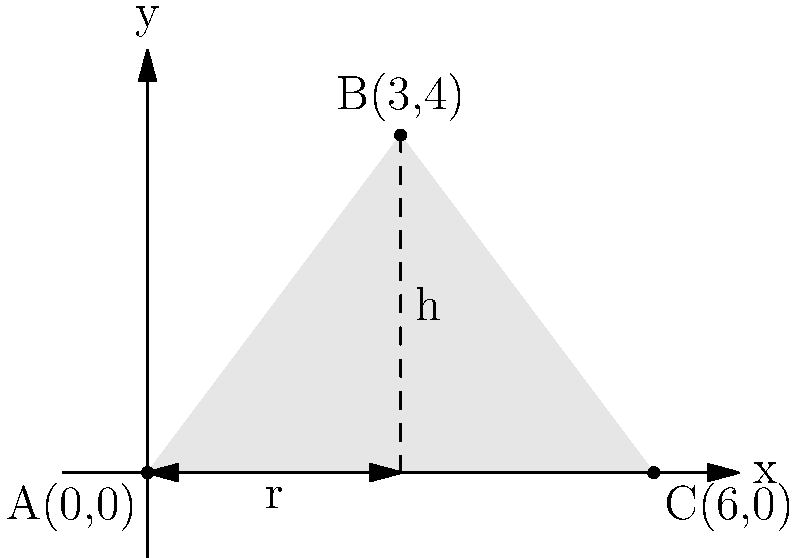As a traditional Egyptian farmer, you use a conical structure to store grains. The base of this structure is circular and rests on the ground. Given the coordinates of three points on the cone: A(0,0), B(3,4), and C(6,0), where the x and y axes are in meters, calculate the volume of the grain storage structure. Use $\pi \approx 3.14$ for your calculations. Let's approach this step-by-step:

1) First, we need to identify the radius and height of the cone:
   - The radius (r) is half the distance between A and C: $r = \frac{6}{2} = 3$ meters
   - The height (h) is the y-coordinate of point B: $h = 4$ meters

2) The volume of a cone is given by the formula: $V = \frac{1}{3}\pi r^2 h$

3) Substituting our values:
   $V = \frac{1}{3} \times 3.14 \times 3^2 \times 4$

4) Calculating:
   $V = \frac{1}{3} \times 3.14 \times 9 \times 4$
   $V = \frac{1}{3} \times 113.04$
   $V = 37.68$ cubic meters

Therefore, the volume of the grain storage structure is approximately 37.68 cubic meters.
Answer: $37.68 \text{ m}^3$ 